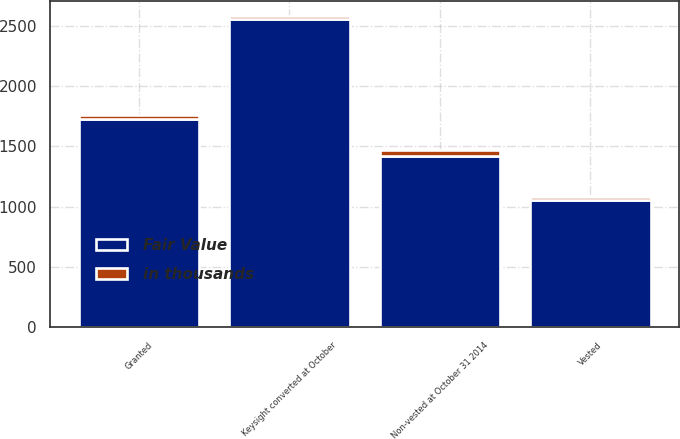<chart> <loc_0><loc_0><loc_500><loc_500><stacked_bar_chart><ecel><fcel>Non-vested at October 31 2014<fcel>Keysight converted at October<fcel>Granted<fcel>Vested<nl><fcel>Fair Value<fcel>1422<fcel>2552<fcel>1725<fcel>1052<nl><fcel>in thousands<fcel>44<fcel>25<fcel>33<fcel>25<nl></chart> 